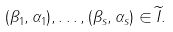Convert formula to latex. <formula><loc_0><loc_0><loc_500><loc_500>( \beta _ { 1 } , \alpha _ { 1 } ) , \dots , ( \beta _ { s } , \alpha _ { s } ) \in \widetilde { I } .</formula> 